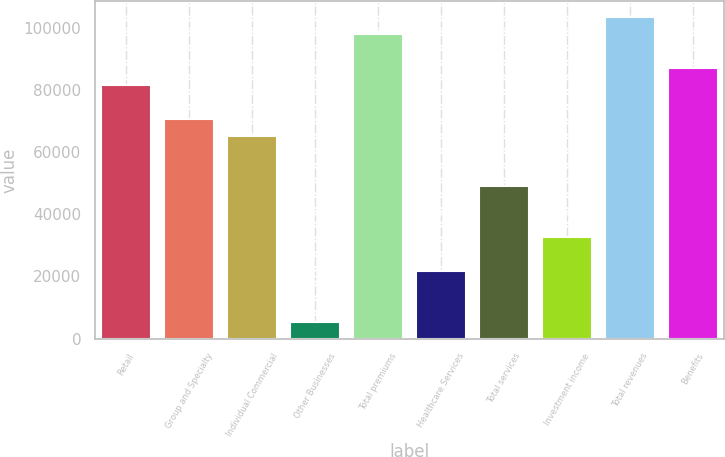<chart> <loc_0><loc_0><loc_500><loc_500><bar_chart><fcel>Retail<fcel>Group and Specialty<fcel>Individual Commercial<fcel>Other Businesses<fcel>Total premiums<fcel>Healthcare Services<fcel>Total services<fcel>Investment income<fcel>Total revenues<fcel>Benefits<nl><fcel>81566.4<fcel>70691.4<fcel>65253.9<fcel>5441.56<fcel>97878.9<fcel>21754<fcel>48941.5<fcel>32629<fcel>103316<fcel>87003.9<nl></chart> 